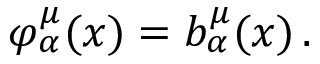Convert formula to latex. <formula><loc_0><loc_0><loc_500><loc_500>\varphi _ { \alpha } ^ { \mu } ( x ) = b _ { \alpha } ^ { \mu } ( x ) \, .</formula> 